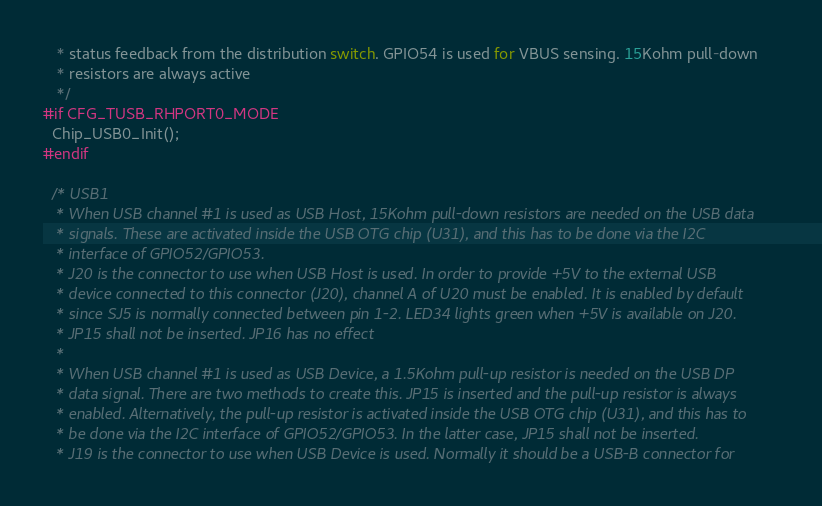Convert code to text. <code><loc_0><loc_0><loc_500><loc_500><_C_>   * status feedback from the distribution switch. GPIO54 is used for VBUS sensing. 15Kohm pull-down
   * resistors are always active
   */
#if CFG_TUSB_RHPORT0_MODE
  Chip_USB0_Init();
#endif

  /* USB1
   * When USB channel #1 is used as USB Host, 15Kohm pull-down resistors are needed on the USB data
   * signals. These are activated inside the USB OTG chip (U31), and this has to be done via the I2C
   * interface of GPIO52/GPIO53.
   * J20 is the connector to use when USB Host is used. In order to provide +5V to the external USB
   * device connected to this connector (J20), channel A of U20 must be enabled. It is enabled by default
   * since SJ5 is normally connected between pin 1-2. LED34 lights green when +5V is available on J20.
   * JP15 shall not be inserted. JP16 has no effect
   *
   * When USB channel #1 is used as USB Device, a 1.5Kohm pull-up resistor is needed on the USB DP
   * data signal. There are two methods to create this. JP15 is inserted and the pull-up resistor is always
   * enabled. Alternatively, the pull-up resistor is activated inside the USB OTG chip (U31), and this has to
   * be done via the I2C interface of GPIO52/GPIO53. In the latter case, JP15 shall not be inserted.
   * J19 is the connector to use when USB Device is used. Normally it should be a USB-B connector for</code> 